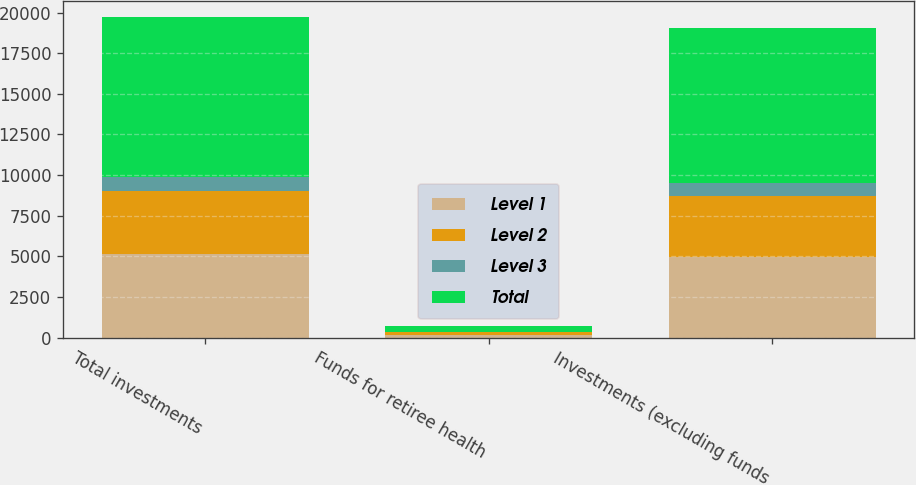Convert chart. <chart><loc_0><loc_0><loc_500><loc_500><stacked_bar_chart><ecel><fcel>Total investments<fcel>Funds for retiree health<fcel>Investments (excluding funds<nl><fcel>Level 1<fcel>5172<fcel>185<fcel>4987<nl><fcel>Level 2<fcel>3853<fcel>137<fcel>3716<nl><fcel>Level 3<fcel>853<fcel>31<fcel>822<nl><fcel>Total<fcel>9878<fcel>353<fcel>9525<nl></chart> 